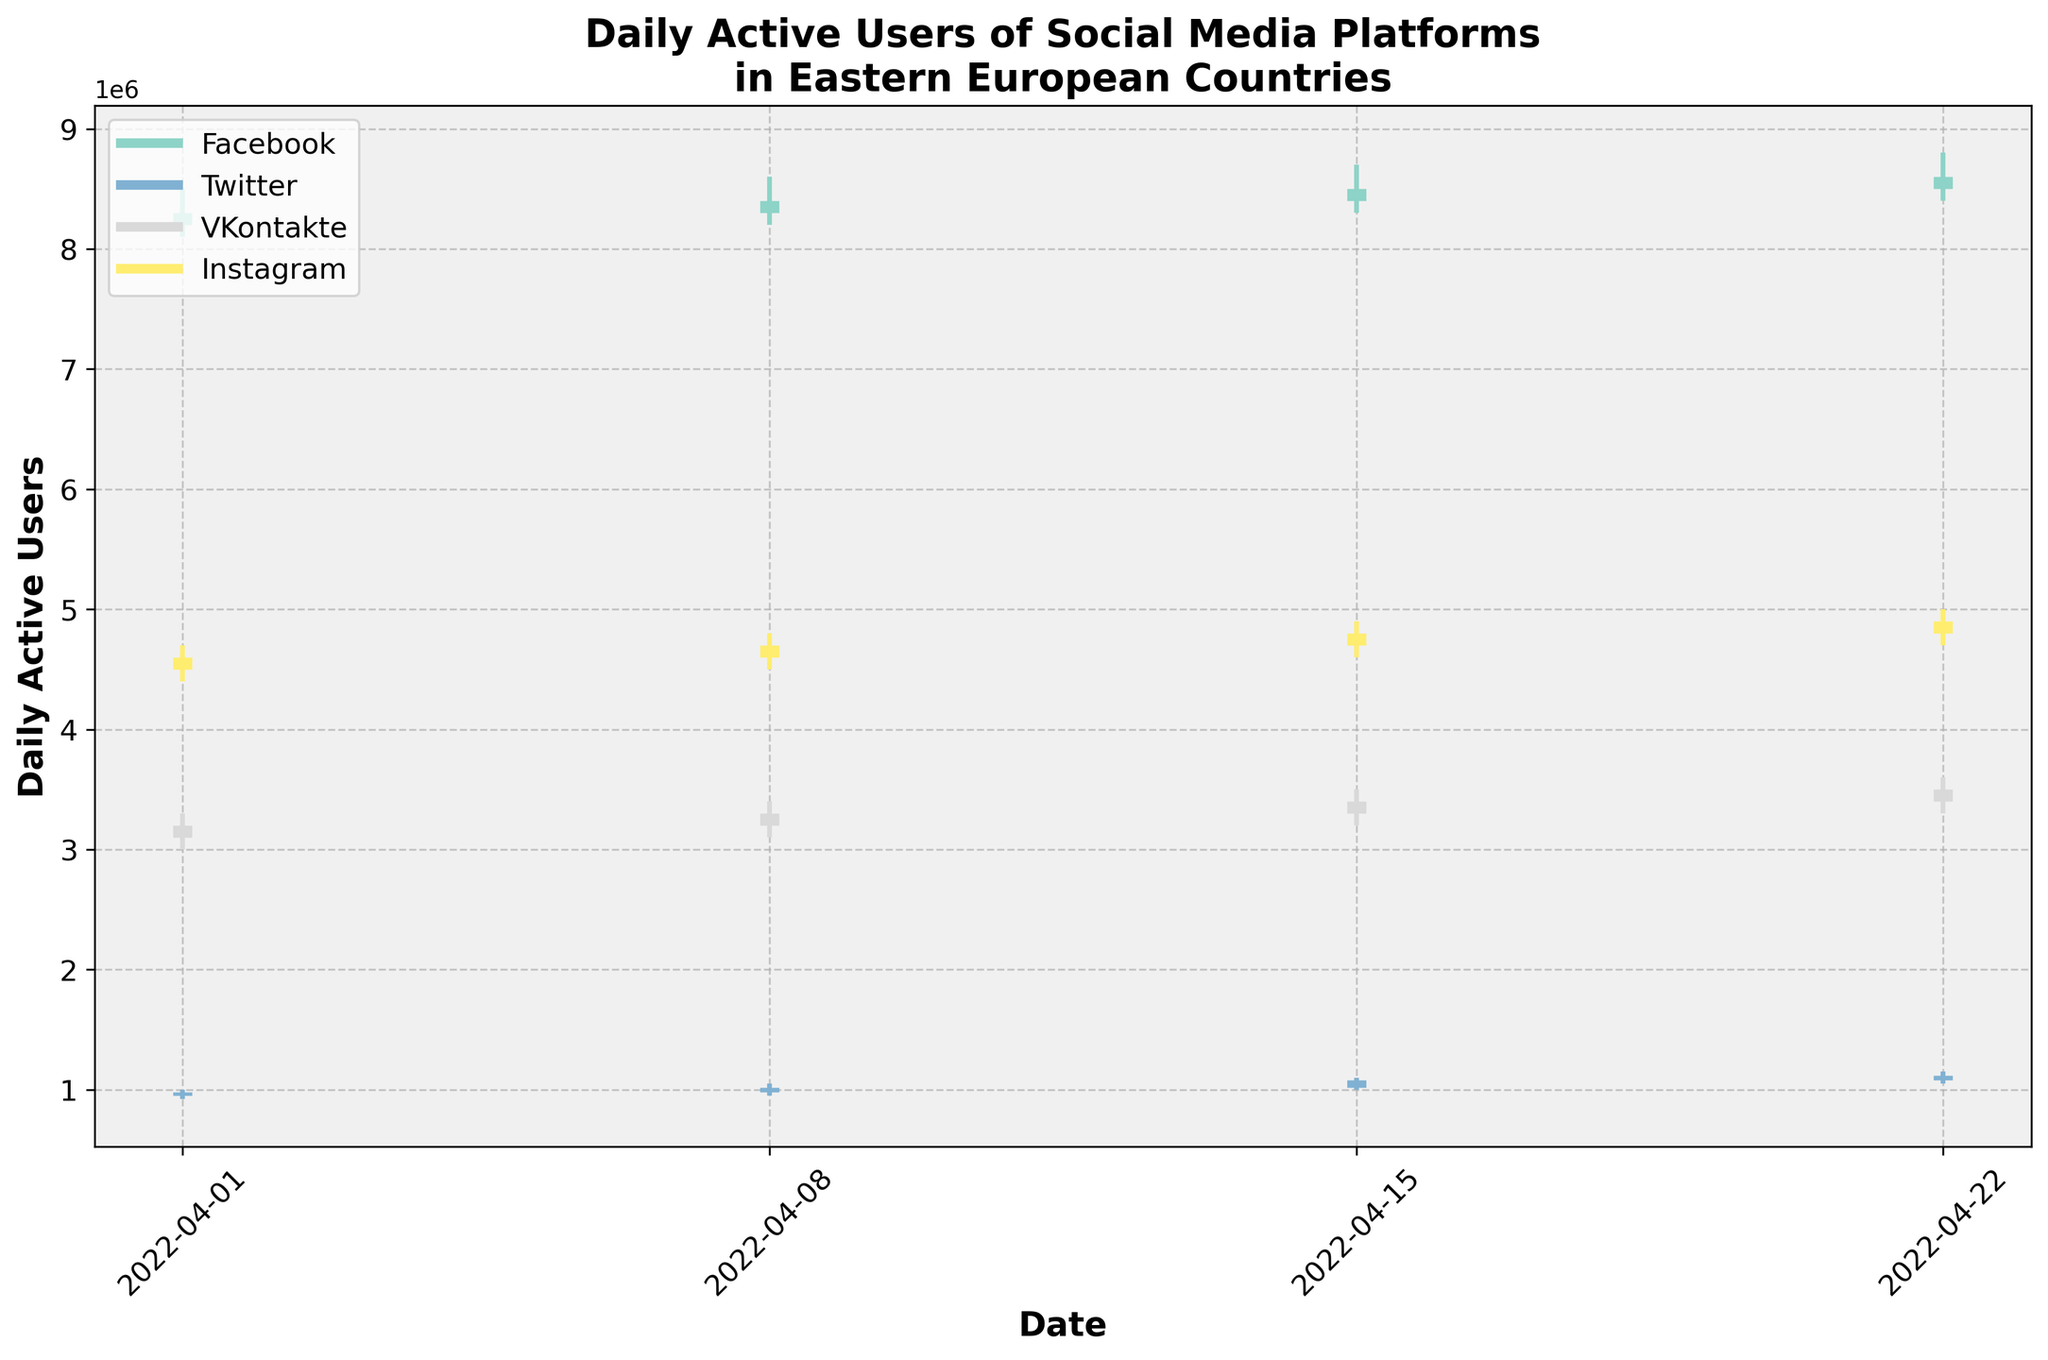What's the title of the figure? The title of the figure is written at the top, summarizing what the figure is about. It reads: "Daily Active Users of Social Media Platforms in Eastern European Countries".
Answer: Daily Active Users of Social Media Platforms in Eastern European Countries On April 22, which platform experienced the highest number of daily active users? By examining the vertical lines on April 22, we can see that Facebook in Poland had the highest value as the maximum data point in that range.
Answer: Facebook Which social media platform shows a consistent increase in daily active users in Poland throughout the given period? We need to look at the OHLC bars for Facebook in Poland. Each subsequent week shows a higher opening and closing value compared to the previous week, indicating a consistent increase.
Answer: Facebook Between Instagram in Romania and VKontakte in Belarus, which platform had higher daily active users on April 8? By comparing the OHLC bars of both platforms on April 8, Instagram in Romania had higher values than VKontakte in Belarus.
Answer: Instagram What is the range (high - low) of Twitter users in Hungary on April 15? For April 15, we subtract the low value from the high value for Twitter in Hungary: 1,100,000 - 1,000,000.
Answer: 100,000 Which platform experienced the largest increase in closing values from April 1 to April 22? To determine the increase, we calculate the close value on April 22 minus the close value on April 1 for each platform. Facebook shows the largest increase from 8,300,000 to 8,600,000.
Answer: Facebook How does the highest value of VKontakte in Belarus on April 8 compare to the highest value on April 15? We need to compare the high values: on April 8, it was 3,400,000 and on April 15, it was 3,500,000. The high value on April 15 is greater.
Answer: April 15 is higher Which date saw the highest closing value for Instagram in Romania? By examining the closing values for Instagram in Romania across all dates, April 22 had the highest closing value of 4,900,000.
Answer: April 22 What is the average closing value for Twitter in Hungary over the given period? We sum all closing values for Twitter in Hungary and divide by the number of dates: (980,000 + 1,020,000 + 1,080,000 + 1,120,000) / 4. The calculation results in 1,050,000.
Answer: 1,050,000 